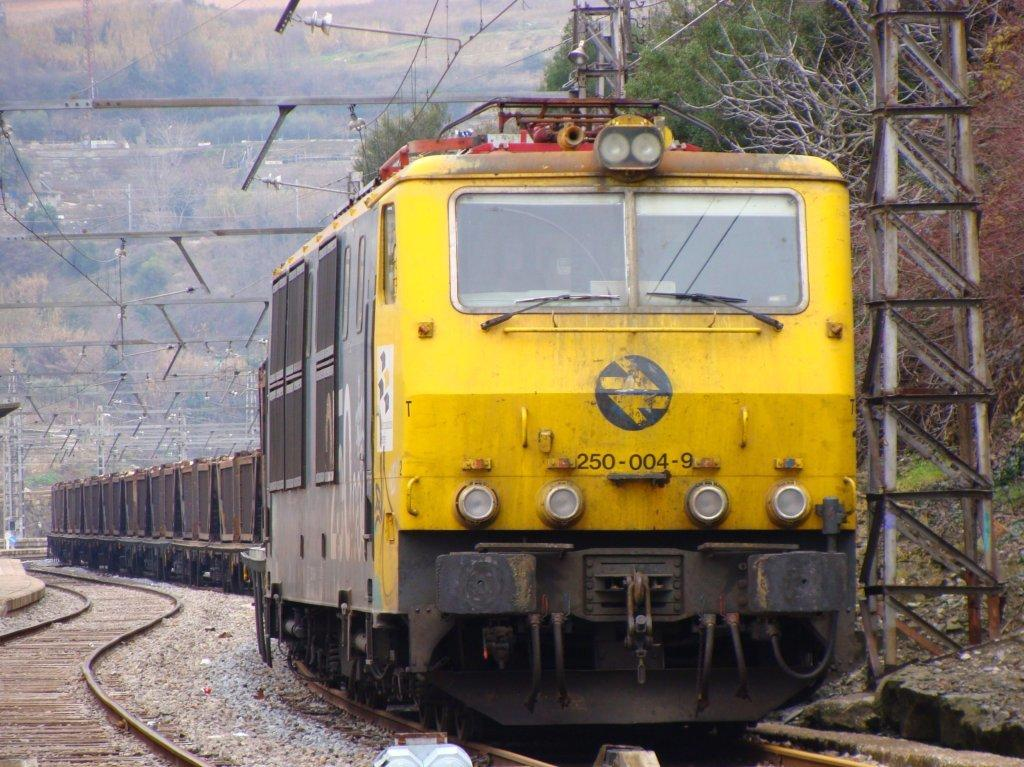<image>
Provide a brief description of the given image. A dirty looking train which has the number 250 visible on the front. 